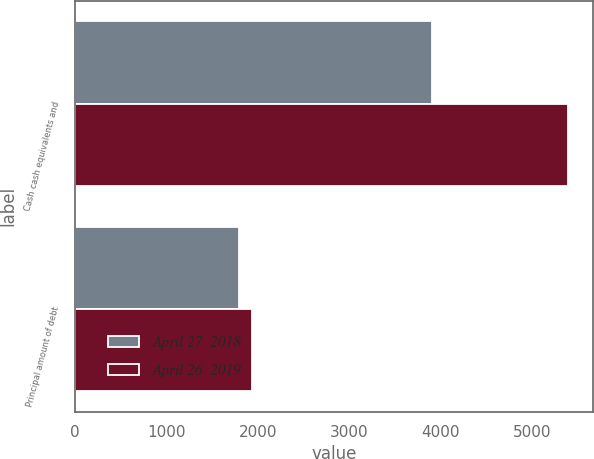Convert chart. <chart><loc_0><loc_0><loc_500><loc_500><stacked_bar_chart><ecel><fcel>Cash cash equivalents and<fcel>Principal amount of debt<nl><fcel>April 27  2018<fcel>3899<fcel>1799<nl><fcel>April 26  2019<fcel>5391<fcel>1935<nl></chart> 